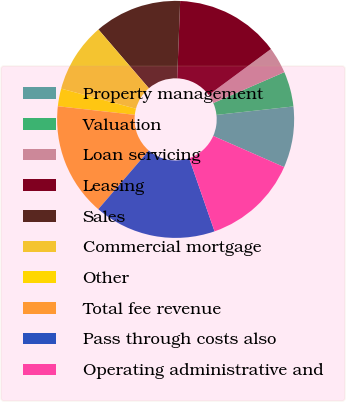Convert chart. <chart><loc_0><loc_0><loc_500><loc_500><pie_chart><fcel>Property management<fcel>Valuation<fcel>Loan servicing<fcel>Leasing<fcel>Sales<fcel>Commercial mortgage<fcel>Other<fcel>Total fee revenue<fcel>Pass through costs also<fcel>Operating administrative and<nl><fcel>8.34%<fcel>4.78%<fcel>3.6%<fcel>14.27%<fcel>11.9%<fcel>9.53%<fcel>2.41%<fcel>15.46%<fcel>16.64%<fcel>13.08%<nl></chart> 